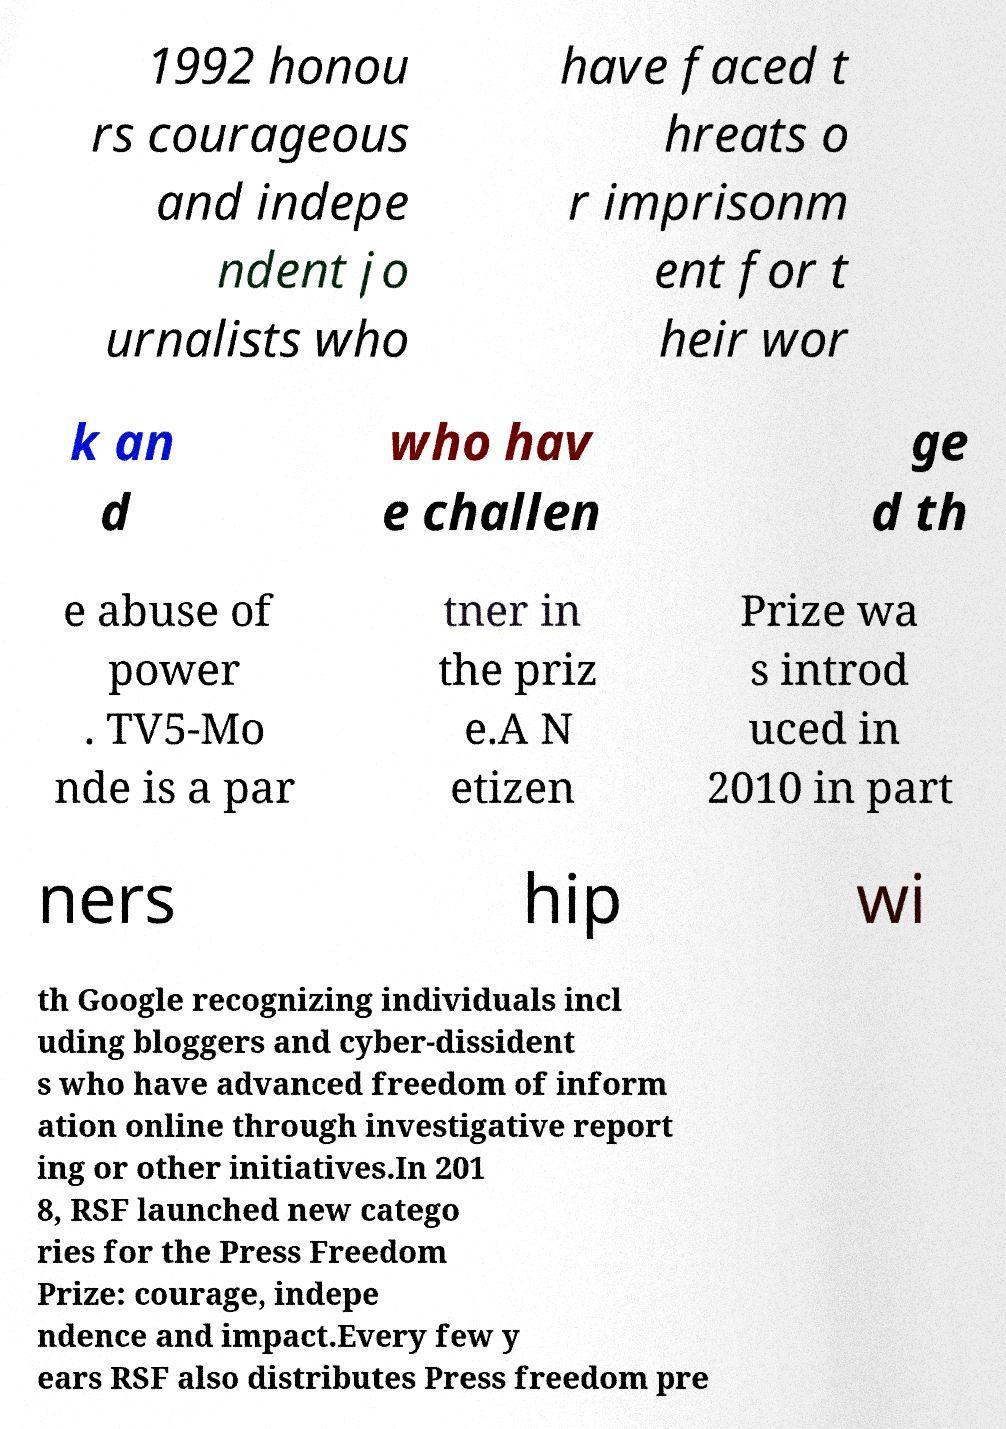Please read and relay the text visible in this image. What does it say? 1992 honou rs courageous and indepe ndent jo urnalists who have faced t hreats o r imprisonm ent for t heir wor k an d who hav e challen ge d th e abuse of power . TV5-Mo nde is a par tner in the priz e.A N etizen Prize wa s introd uced in 2010 in part ners hip wi th Google recognizing individuals incl uding bloggers and cyber-dissident s who have advanced freedom of inform ation online through investigative report ing or other initiatives.In 201 8, RSF launched new catego ries for the Press Freedom Prize: courage, indepe ndence and impact.Every few y ears RSF also distributes Press freedom pre 